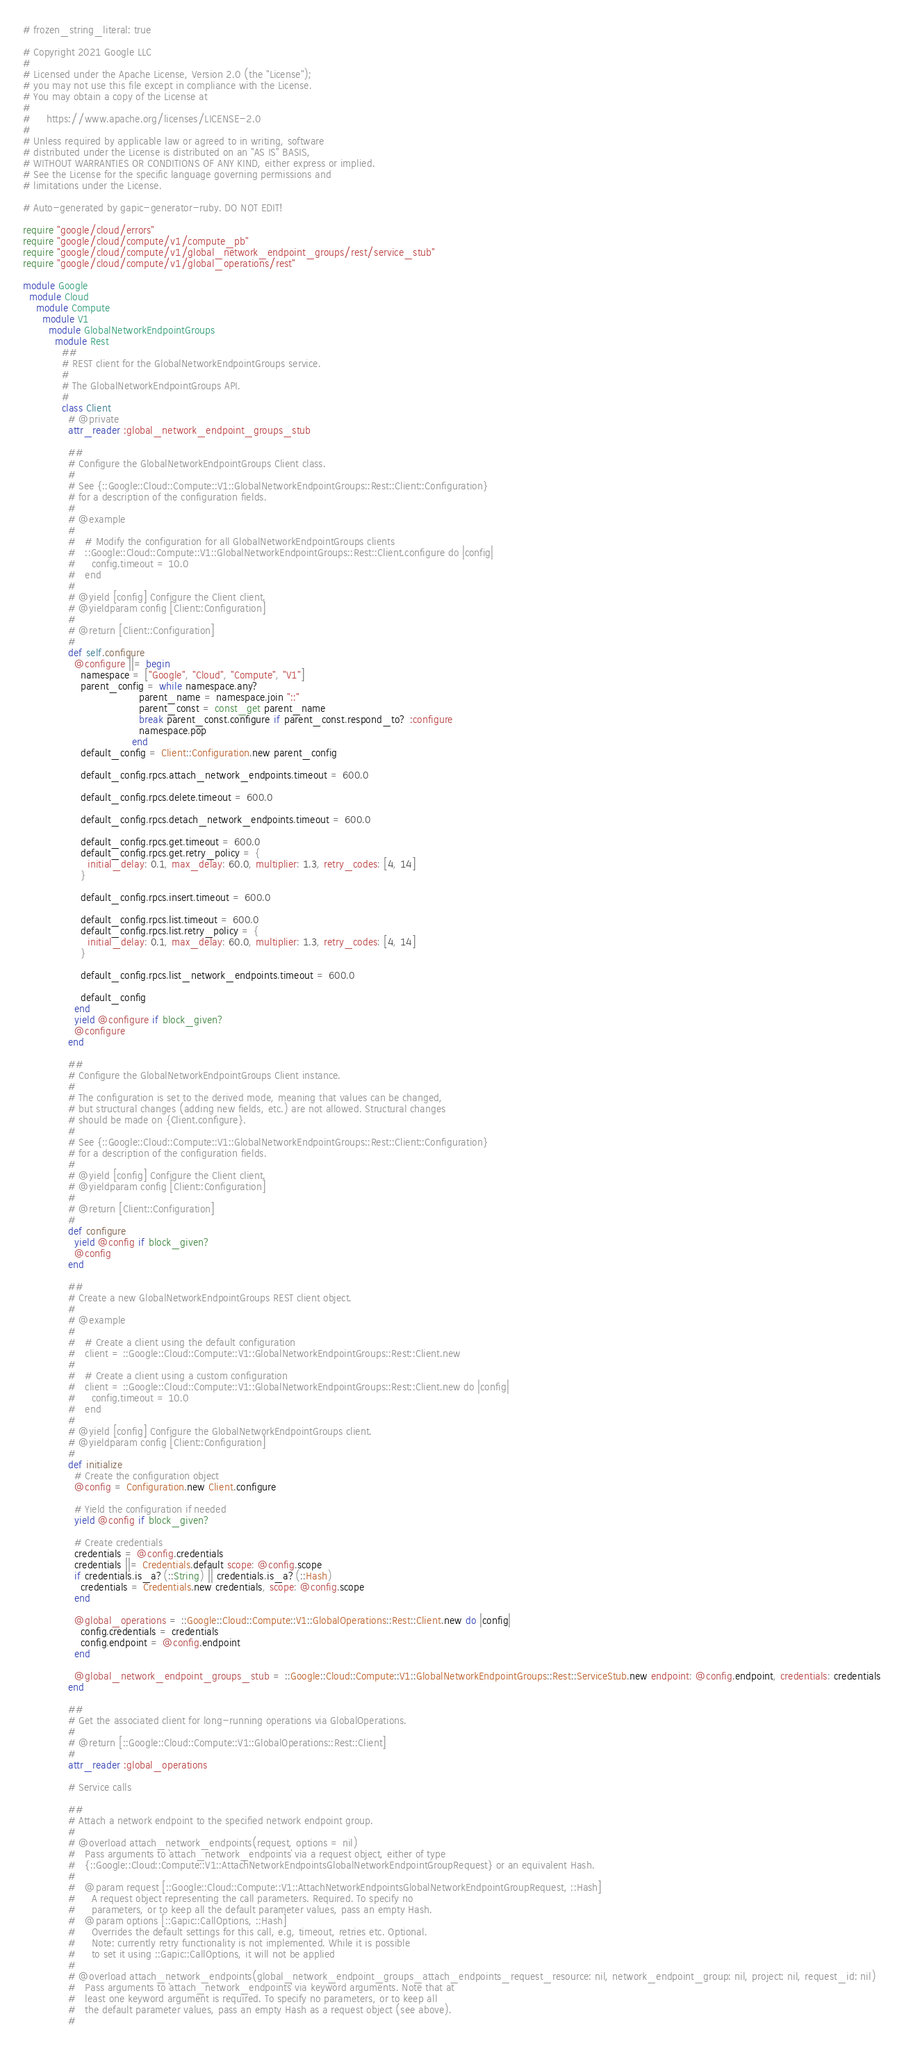<code> <loc_0><loc_0><loc_500><loc_500><_Ruby_># frozen_string_literal: true

# Copyright 2021 Google LLC
#
# Licensed under the Apache License, Version 2.0 (the "License");
# you may not use this file except in compliance with the License.
# You may obtain a copy of the License at
#
#     https://www.apache.org/licenses/LICENSE-2.0
#
# Unless required by applicable law or agreed to in writing, software
# distributed under the License is distributed on an "AS IS" BASIS,
# WITHOUT WARRANTIES OR CONDITIONS OF ANY KIND, either express or implied.
# See the License for the specific language governing permissions and
# limitations under the License.

# Auto-generated by gapic-generator-ruby. DO NOT EDIT!

require "google/cloud/errors"
require "google/cloud/compute/v1/compute_pb"
require "google/cloud/compute/v1/global_network_endpoint_groups/rest/service_stub"
require "google/cloud/compute/v1/global_operations/rest"

module Google
  module Cloud
    module Compute
      module V1
        module GlobalNetworkEndpointGroups
          module Rest
            ##
            # REST client for the GlobalNetworkEndpointGroups service.
            #
            # The GlobalNetworkEndpointGroups API.
            #
            class Client
              # @private
              attr_reader :global_network_endpoint_groups_stub

              ##
              # Configure the GlobalNetworkEndpointGroups Client class.
              #
              # See {::Google::Cloud::Compute::V1::GlobalNetworkEndpointGroups::Rest::Client::Configuration}
              # for a description of the configuration fields.
              #
              # @example
              #
              #   # Modify the configuration for all GlobalNetworkEndpointGroups clients
              #   ::Google::Cloud::Compute::V1::GlobalNetworkEndpointGroups::Rest::Client.configure do |config|
              #     config.timeout = 10.0
              #   end
              #
              # @yield [config] Configure the Client client.
              # @yieldparam config [Client::Configuration]
              #
              # @return [Client::Configuration]
              #
              def self.configure
                @configure ||= begin
                  namespace = ["Google", "Cloud", "Compute", "V1"]
                  parent_config = while namespace.any?
                                    parent_name = namespace.join "::"
                                    parent_const = const_get parent_name
                                    break parent_const.configure if parent_const.respond_to? :configure
                                    namespace.pop
                                  end
                  default_config = Client::Configuration.new parent_config

                  default_config.rpcs.attach_network_endpoints.timeout = 600.0

                  default_config.rpcs.delete.timeout = 600.0

                  default_config.rpcs.detach_network_endpoints.timeout = 600.0

                  default_config.rpcs.get.timeout = 600.0
                  default_config.rpcs.get.retry_policy = {
                    initial_delay: 0.1, max_delay: 60.0, multiplier: 1.3, retry_codes: [4, 14]
                  }

                  default_config.rpcs.insert.timeout = 600.0

                  default_config.rpcs.list.timeout = 600.0
                  default_config.rpcs.list.retry_policy = {
                    initial_delay: 0.1, max_delay: 60.0, multiplier: 1.3, retry_codes: [4, 14]
                  }

                  default_config.rpcs.list_network_endpoints.timeout = 600.0

                  default_config
                end
                yield @configure if block_given?
                @configure
              end

              ##
              # Configure the GlobalNetworkEndpointGroups Client instance.
              #
              # The configuration is set to the derived mode, meaning that values can be changed,
              # but structural changes (adding new fields, etc.) are not allowed. Structural changes
              # should be made on {Client.configure}.
              #
              # See {::Google::Cloud::Compute::V1::GlobalNetworkEndpointGroups::Rest::Client::Configuration}
              # for a description of the configuration fields.
              #
              # @yield [config] Configure the Client client.
              # @yieldparam config [Client::Configuration]
              #
              # @return [Client::Configuration]
              #
              def configure
                yield @config if block_given?
                @config
              end

              ##
              # Create a new GlobalNetworkEndpointGroups REST client object.
              #
              # @example
              #
              #   # Create a client using the default configuration
              #   client = ::Google::Cloud::Compute::V1::GlobalNetworkEndpointGroups::Rest::Client.new
              #
              #   # Create a client using a custom configuration
              #   client = ::Google::Cloud::Compute::V1::GlobalNetworkEndpointGroups::Rest::Client.new do |config|
              #     config.timeout = 10.0
              #   end
              #
              # @yield [config] Configure the GlobalNetworkEndpointGroups client.
              # @yieldparam config [Client::Configuration]
              #
              def initialize
                # Create the configuration object
                @config = Configuration.new Client.configure

                # Yield the configuration if needed
                yield @config if block_given?

                # Create credentials
                credentials = @config.credentials
                credentials ||= Credentials.default scope: @config.scope
                if credentials.is_a?(::String) || credentials.is_a?(::Hash)
                  credentials = Credentials.new credentials, scope: @config.scope
                end

                @global_operations = ::Google::Cloud::Compute::V1::GlobalOperations::Rest::Client.new do |config|
                  config.credentials = credentials
                  config.endpoint = @config.endpoint
                end

                @global_network_endpoint_groups_stub = ::Google::Cloud::Compute::V1::GlobalNetworkEndpointGroups::Rest::ServiceStub.new endpoint: @config.endpoint, credentials: credentials
              end

              ##
              # Get the associated client for long-running operations via GlobalOperations.
              #
              # @return [::Google::Cloud::Compute::V1::GlobalOperations::Rest::Client]
              #
              attr_reader :global_operations

              # Service calls

              ##
              # Attach a network endpoint to the specified network endpoint group.
              #
              # @overload attach_network_endpoints(request, options = nil)
              #   Pass arguments to `attach_network_endpoints` via a request object, either of type
              #   {::Google::Cloud::Compute::V1::AttachNetworkEndpointsGlobalNetworkEndpointGroupRequest} or an equivalent Hash.
              #
              #   @param request [::Google::Cloud::Compute::V1::AttachNetworkEndpointsGlobalNetworkEndpointGroupRequest, ::Hash]
              #     A request object representing the call parameters. Required. To specify no
              #     parameters, or to keep all the default parameter values, pass an empty Hash.
              #   @param options [::Gapic::CallOptions, ::Hash]
              #     Overrides the default settings for this call, e.g, timeout, retries etc. Optional.
              #     Note: currently retry functionality is not implemented. While it is possible
              #     to set it using ::Gapic::CallOptions, it will not be applied
              #
              # @overload attach_network_endpoints(global_network_endpoint_groups_attach_endpoints_request_resource: nil, network_endpoint_group: nil, project: nil, request_id: nil)
              #   Pass arguments to `attach_network_endpoints` via keyword arguments. Note that at
              #   least one keyword argument is required. To specify no parameters, or to keep all
              #   the default parameter values, pass an empty Hash as a request object (see above).
              #</code> 